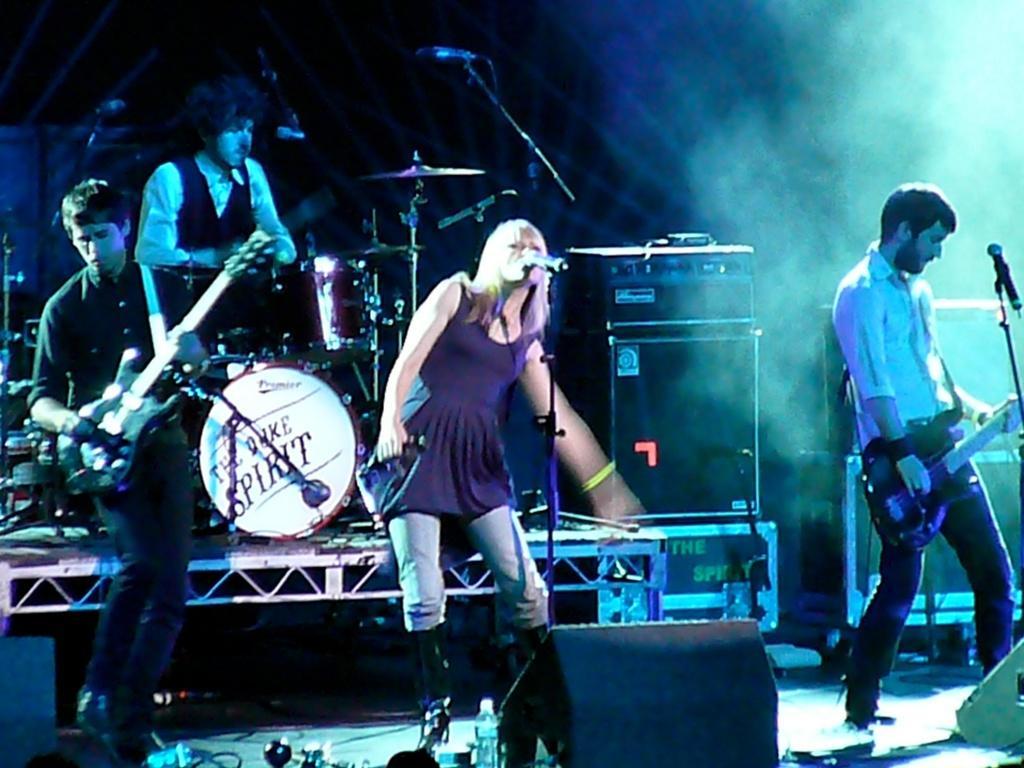In one or two sentences, can you explain what this image depicts? In this image we can see people playing musical instruments. In the center of the image there is a girl singing song in a mic. 